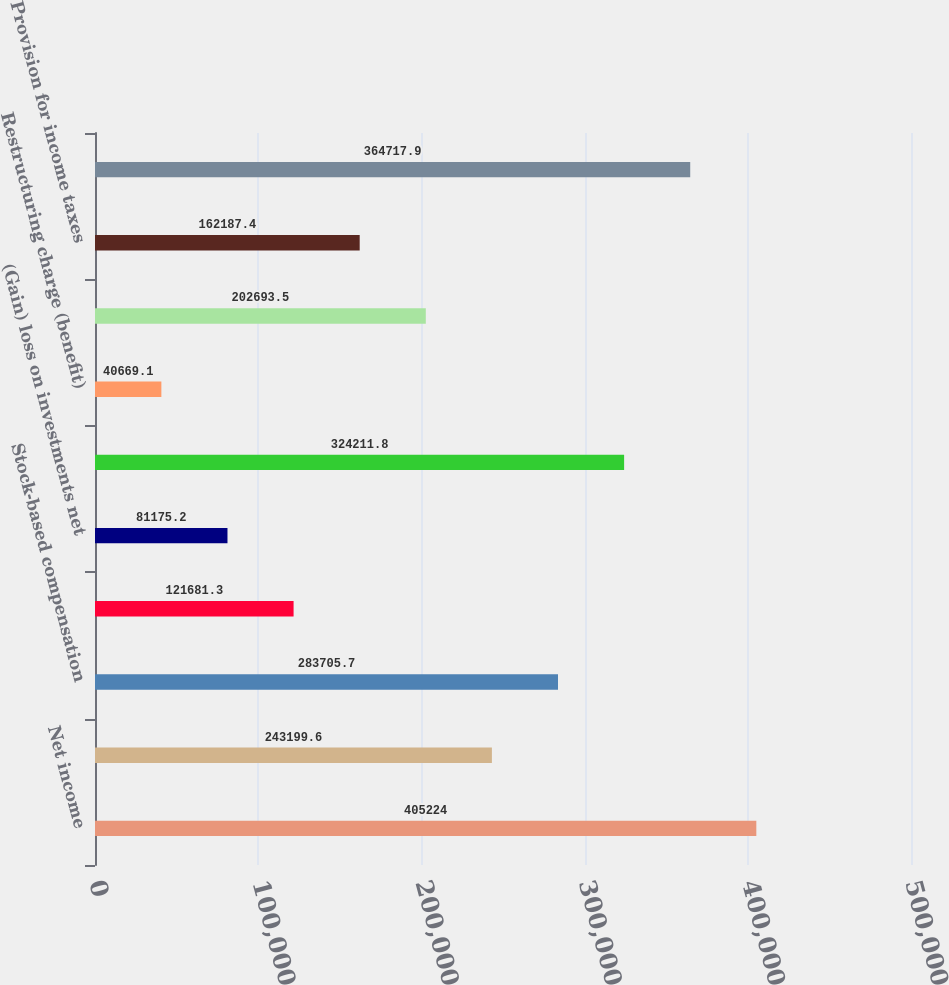<chart> <loc_0><loc_0><loc_500><loc_500><bar_chart><fcel>Net income<fcel>Amortization of other acquired<fcel>Stock-based compensation<fcel>Amortization of capitalized<fcel>(Gain) loss on investments net<fcel>Utilization of tax<fcel>Restructuring charge (benefit)<fcel>Interest income net of<fcel>Provision for income taxes<fcel>Depreciation and amortization<nl><fcel>405224<fcel>243200<fcel>283706<fcel>121681<fcel>81175.2<fcel>324212<fcel>40669.1<fcel>202694<fcel>162187<fcel>364718<nl></chart> 